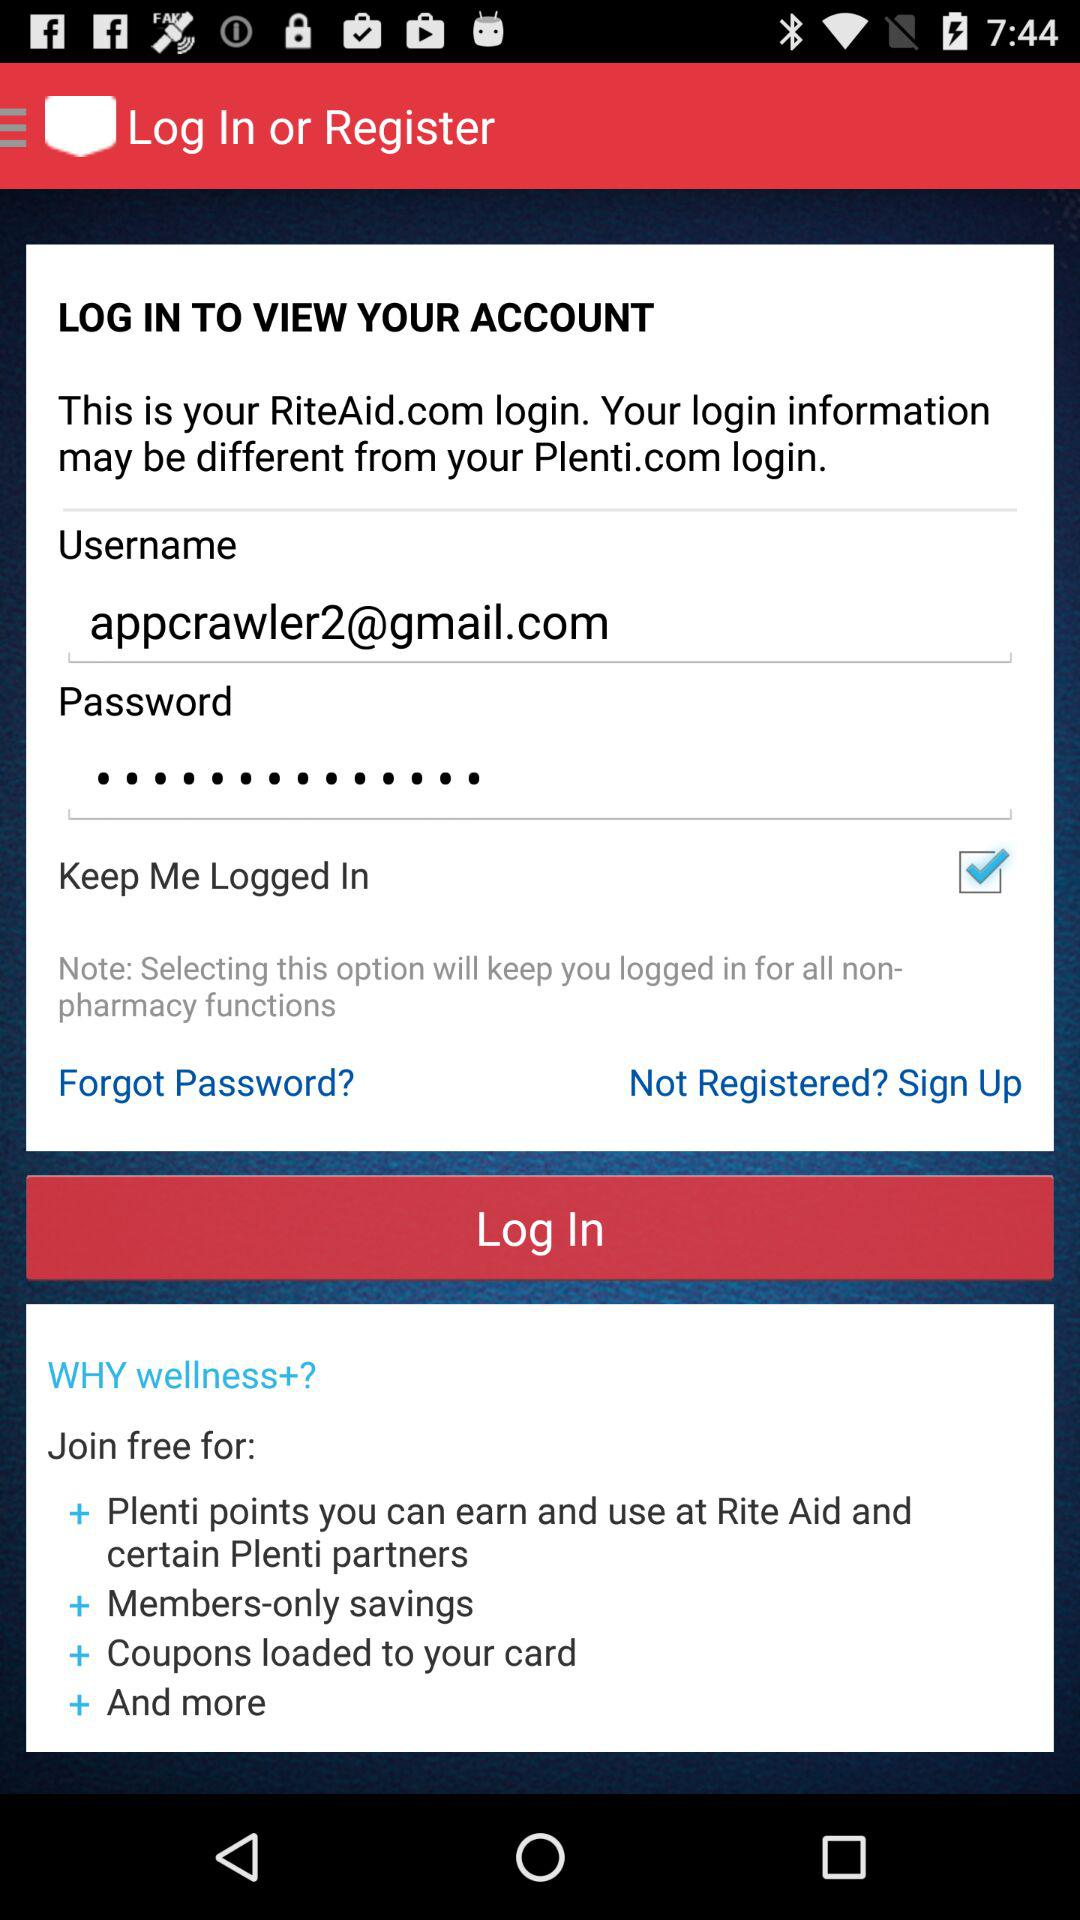Where is the nearest Rite Aid location?
When the provided information is insufficient, respond with <no answer>. <no answer> 